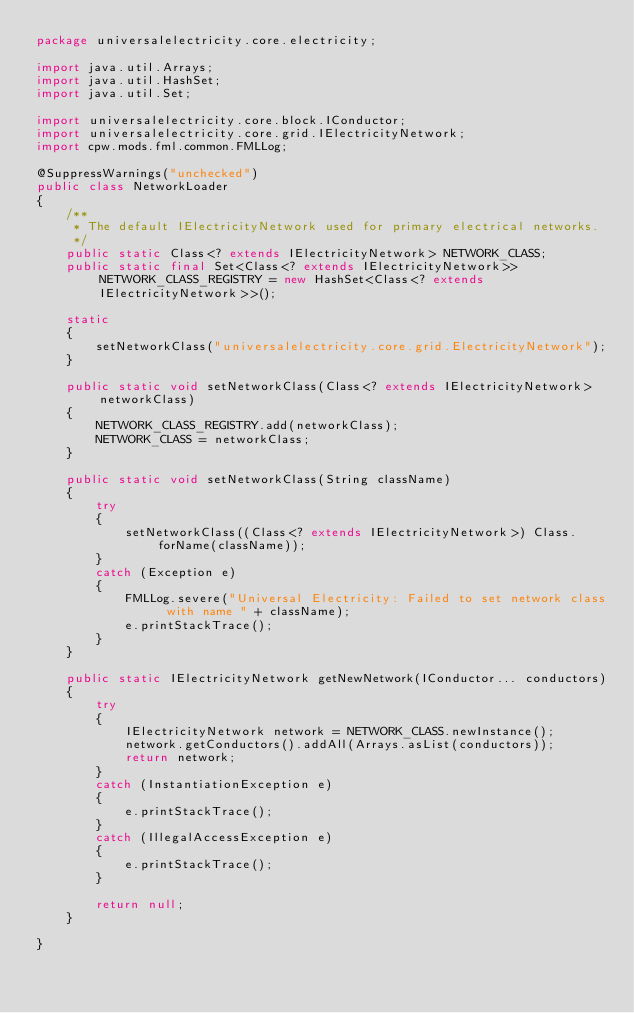<code> <loc_0><loc_0><loc_500><loc_500><_Java_>package universalelectricity.core.electricity;

import java.util.Arrays;
import java.util.HashSet;
import java.util.Set;

import universalelectricity.core.block.IConductor;
import universalelectricity.core.grid.IElectricityNetwork;
import cpw.mods.fml.common.FMLLog;

@SuppressWarnings("unchecked")
public class NetworkLoader
{
	/**
	 * The default IElectricityNetwork used for primary electrical networks.
	 */
	public static Class<? extends IElectricityNetwork> NETWORK_CLASS;
	public static final Set<Class<? extends IElectricityNetwork>> NETWORK_CLASS_REGISTRY = new HashSet<Class<? extends IElectricityNetwork>>();

	static
	{
		setNetworkClass("universalelectricity.core.grid.ElectricityNetwork");
	}

	public static void setNetworkClass(Class<? extends IElectricityNetwork> networkClass)
	{
		NETWORK_CLASS_REGISTRY.add(networkClass);
		NETWORK_CLASS = networkClass;
	}

	public static void setNetworkClass(String className)
	{
		try
		{
			setNetworkClass((Class<? extends IElectricityNetwork>) Class.forName(className));
		}
		catch (Exception e)
		{
			FMLLog.severe("Universal Electricity: Failed to set network class with name " + className);
			e.printStackTrace();
		}
	}

	public static IElectricityNetwork getNewNetwork(IConductor... conductors)
	{
		try
		{
			IElectricityNetwork network = NETWORK_CLASS.newInstance();
			network.getConductors().addAll(Arrays.asList(conductors));
			return network;
		}
		catch (InstantiationException e)
		{
			e.printStackTrace();
		}
		catch (IllegalAccessException e)
		{
			e.printStackTrace();
		}

		return null;
	}

}</code> 